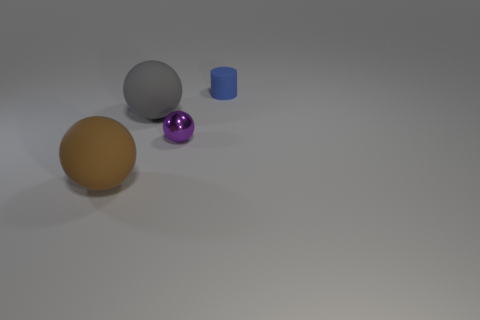Add 3 brown metal spheres. How many objects exist? 7 Subtract all balls. How many objects are left? 1 Add 1 blue cylinders. How many blue cylinders are left? 2 Add 2 tiny purple shiny objects. How many tiny purple shiny objects exist? 3 Subtract 0 green cylinders. How many objects are left? 4 Subtract all small purple shiny balls. Subtract all tiny rubber things. How many objects are left? 2 